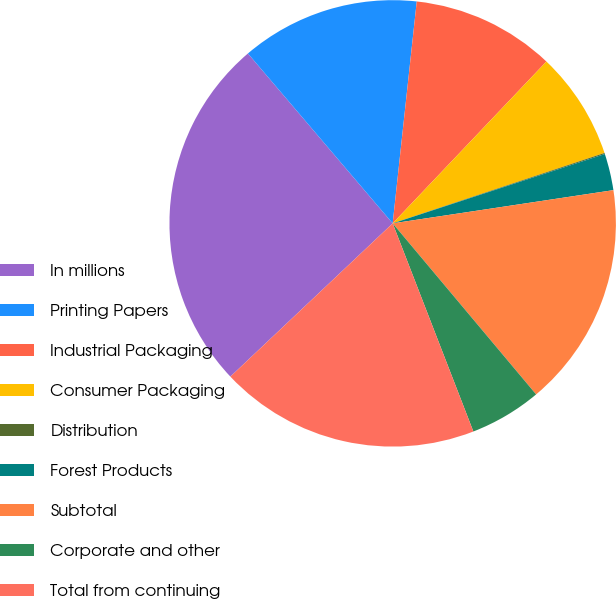Convert chart. <chart><loc_0><loc_0><loc_500><loc_500><pie_chart><fcel>In millions<fcel>Printing Papers<fcel>Industrial Packaging<fcel>Consumer Packaging<fcel>Distribution<fcel>Forest Products<fcel>Subtotal<fcel>Corporate and other<fcel>Total from continuing<nl><fcel>25.81%<fcel>12.95%<fcel>10.37%<fcel>7.8%<fcel>0.08%<fcel>2.65%<fcel>16.27%<fcel>5.22%<fcel>18.84%<nl></chart> 